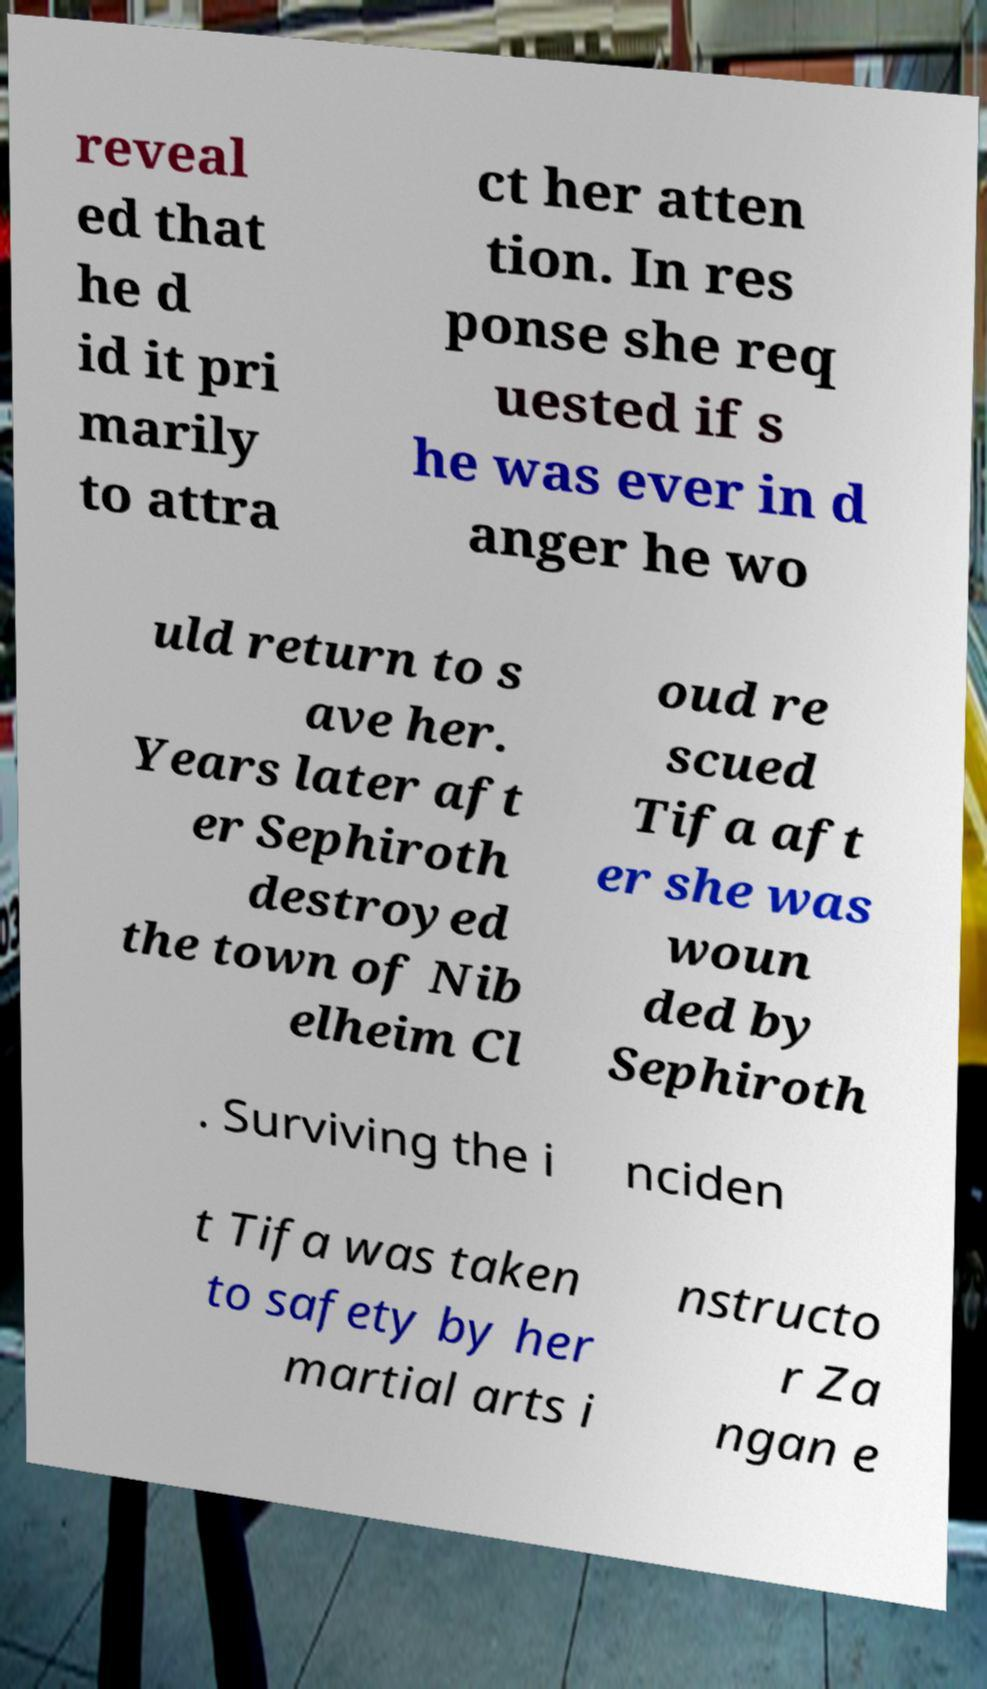What messages or text are displayed in this image? I need them in a readable, typed format. reveal ed that he d id it pri marily to attra ct her atten tion. In res ponse she req uested if s he was ever in d anger he wo uld return to s ave her. Years later aft er Sephiroth destroyed the town of Nib elheim Cl oud re scued Tifa aft er she was woun ded by Sephiroth . Surviving the i nciden t Tifa was taken to safety by her martial arts i nstructo r Za ngan e 